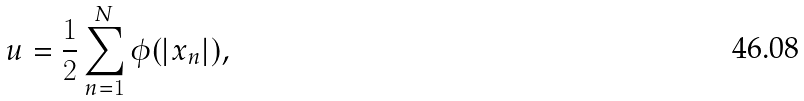<formula> <loc_0><loc_0><loc_500><loc_500>u = \frac { 1 } { 2 } \sum _ { n = 1 } ^ { N } \phi ( | { x } _ { n } | ) ,</formula> 